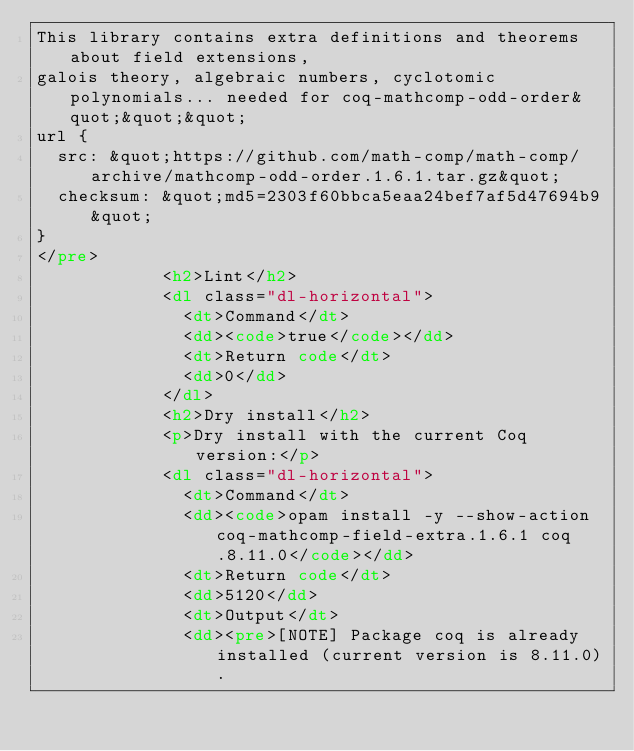Convert code to text. <code><loc_0><loc_0><loc_500><loc_500><_HTML_>This library contains extra definitions and theorems about field extensions,
galois theory, algebraic numbers, cyclotomic polynomials... needed for coq-mathcomp-odd-order&quot;&quot;&quot;
url {
  src: &quot;https://github.com/math-comp/math-comp/archive/mathcomp-odd-order.1.6.1.tar.gz&quot;
  checksum: &quot;md5=2303f60bbca5eaa24bef7af5d47694b9&quot;
}
</pre>
            <h2>Lint</h2>
            <dl class="dl-horizontal">
              <dt>Command</dt>
              <dd><code>true</code></dd>
              <dt>Return code</dt>
              <dd>0</dd>
            </dl>
            <h2>Dry install</h2>
            <p>Dry install with the current Coq version:</p>
            <dl class="dl-horizontal">
              <dt>Command</dt>
              <dd><code>opam install -y --show-action coq-mathcomp-field-extra.1.6.1 coq.8.11.0</code></dd>
              <dt>Return code</dt>
              <dd>5120</dd>
              <dt>Output</dt>
              <dd><pre>[NOTE] Package coq is already installed (current version is 8.11.0).</code> 